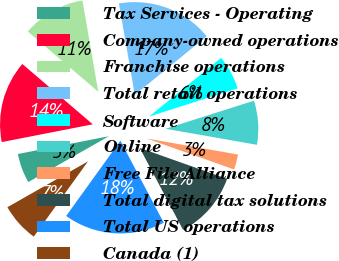Convert chart. <chart><loc_0><loc_0><loc_500><loc_500><pie_chart><fcel>Tax Services - Operating<fcel>Company-owned operations<fcel>Franchise operations<fcel>Total retail operations<fcel>Software<fcel>Online<fcel>Free File Alliance<fcel>Total digital tax solutions<fcel>Total US operations<fcel>Canada (1)<nl><fcel>5.16%<fcel>14.34%<fcel>11.0%<fcel>16.85%<fcel>5.99%<fcel>7.66%<fcel>2.65%<fcel>11.84%<fcel>17.68%<fcel>6.83%<nl></chart> 